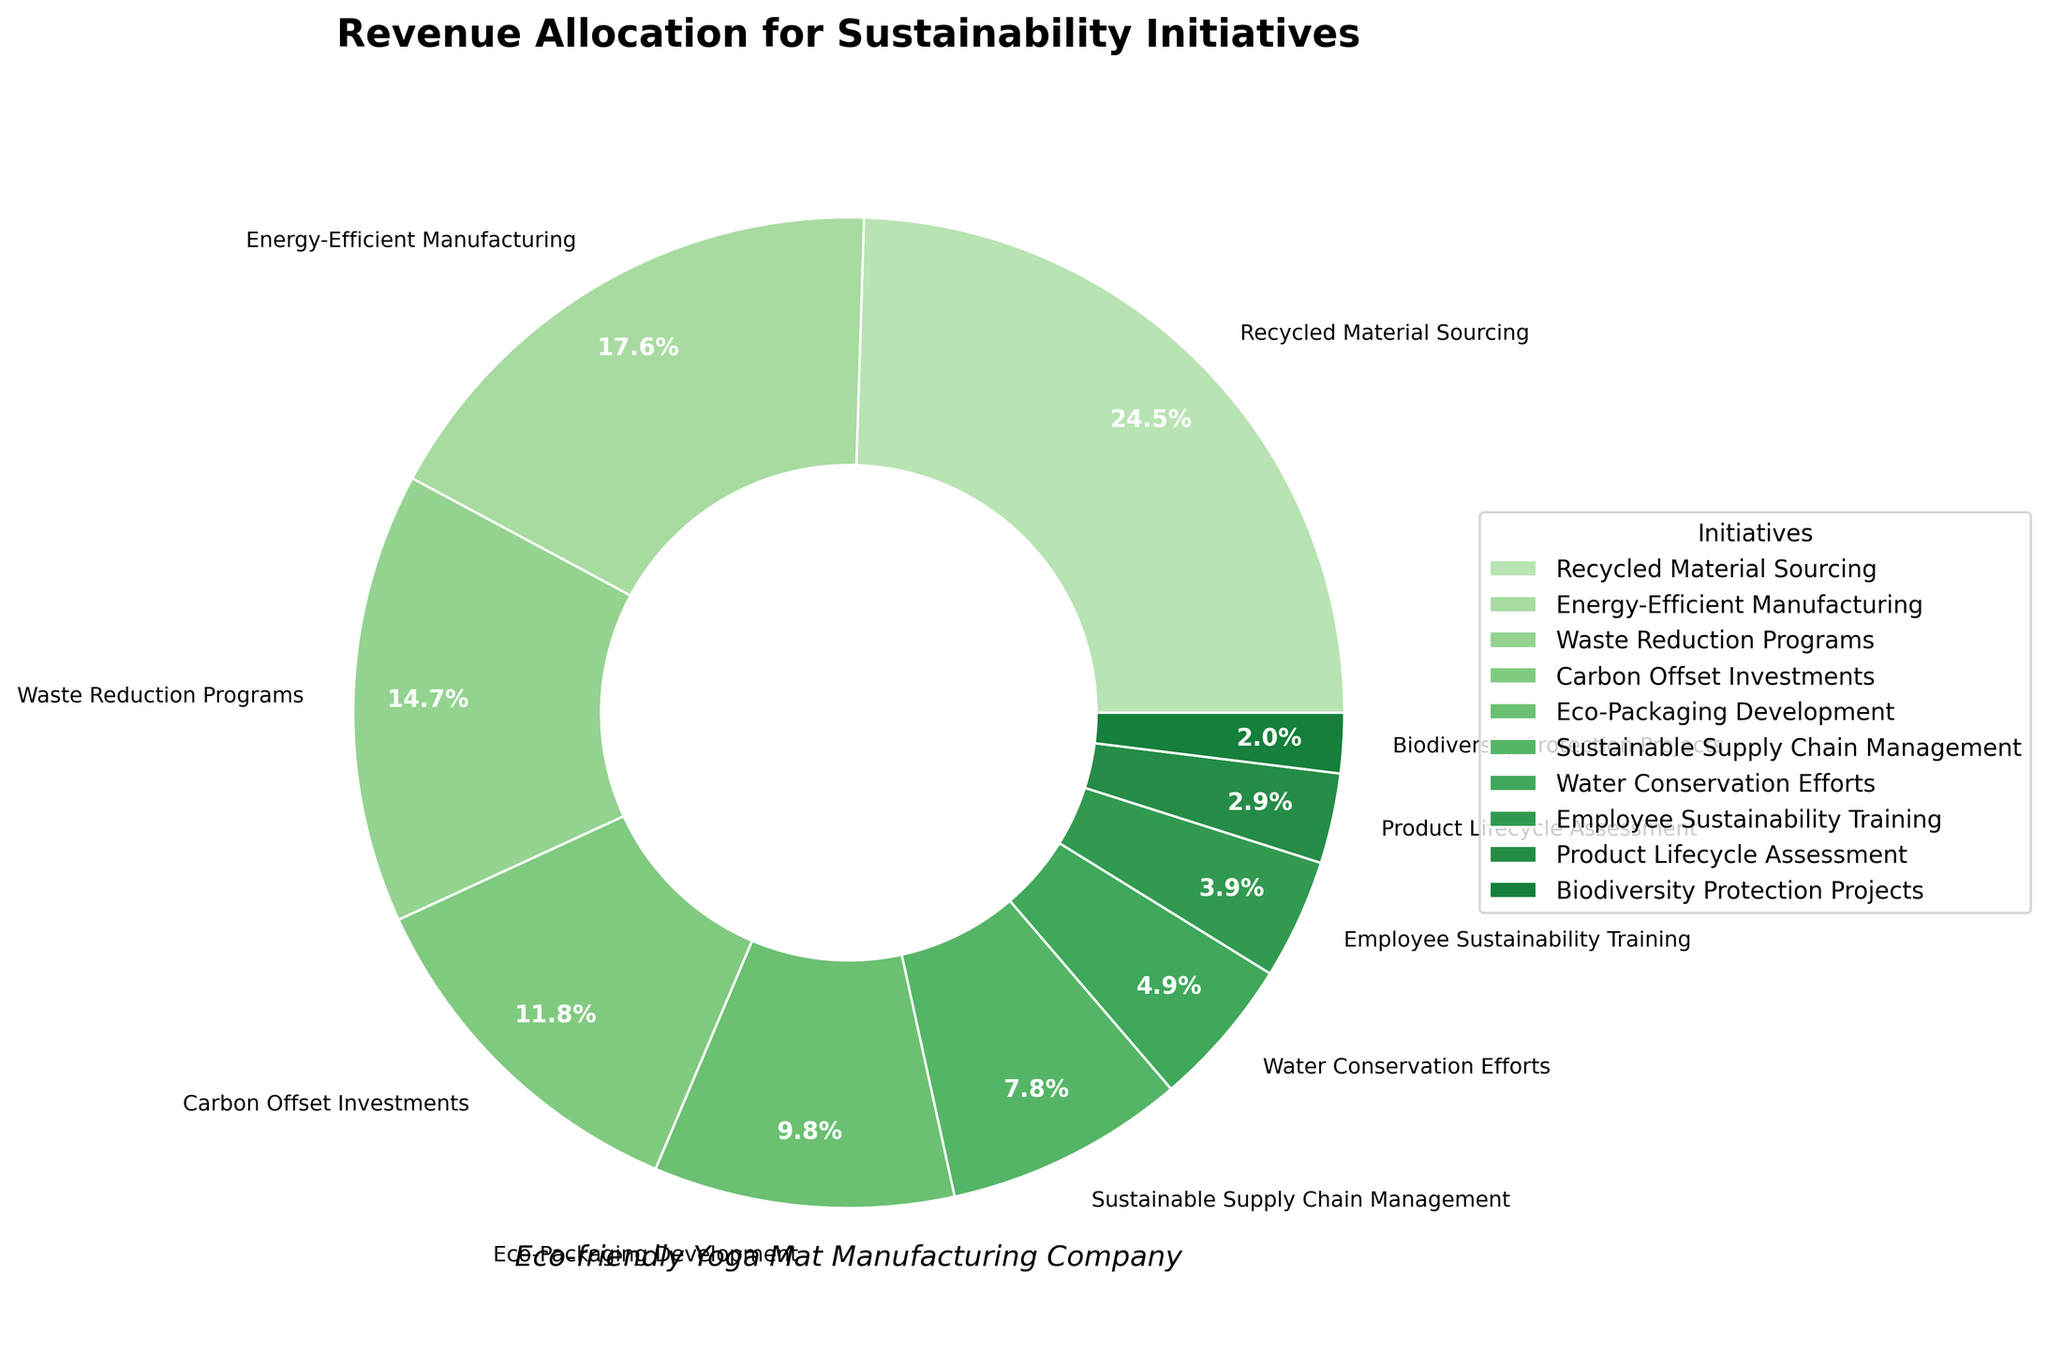Which initiative received the highest percentage of the revenue allocation? The initiative with the largest slice in the pie chart indicates the highest revenue allocation, which is "Recycled Material Sourcing" at 25%.
Answer: Recycled Material Sourcing Calculate the combined percentage of revenue allocation for "Eco-Packaging Development", "Sustainable Supply Chain Management", and "Water Conservation Efforts". Sum the percentages for each of these initiatives: 10% + 8% + 5% = 23%.
Answer: 23% How much more percentage is allocated to "Energy-Efficient Manufacturing" than "Employee Sustainability Training"? Subtract the percentage of "Employee Sustainability Training" from "Energy-Efficient Manufacturing": 18% - 4% = 14%.
Answer: 14% Which initiative has a lower allocation: "Carbon Offset Investments" or "Waste Reduction Programs"? "Waste Reduction Programs" has 15% and "Carbon Offset Investments" has 12%, so "Carbon Offset Investments" has a lower allocation.
Answer: Carbon Offset Investments What is the total percentage of revenue allocation for initiatives aimed at reducing environmental impact, such as "Waste Reduction Programs", "Carbon Offset Investments", and "Water Conservation Efforts"? Sum the percentages for each of these initiatives: 15% + 12% + 5% = 32%.
Answer: 32% How many initiatives have an allocation of less than 10%? Count the initiatives with percentages less than 10%: "Sustainable Supply Chain Management" (8%), "Water Conservation Efforts" (5%), "Employee Sustainability Training" (4%), "Product Lifecycle Assessment" (3%), "Biodiversity Protection Projects" (2%). There are 5 initiatives.
Answer: 5 Compare the allocation for "Recycled Material Sourcing" and "Energy-Efficient Manufacturing". Which is higher and by how much? "Recycled Material Sourcing" is 25%, and "Energy-Efficient Manufacturing" is 18%. Subtract the smaller percentage from the larger: 25% - 18% = 7%. "Recycled Material Sourcing" is higher by 7%.
Answer: Recycled Material Sourcing by 7% Is the allocation for "Water Conservation Efforts" greater than that for "Product Lifecycle Assessment"? "Water Conservation Efforts" has 5%, and "Product Lifecycle Assessment" has 3%. 5% is greater than 3%.
Answer: Yes What percentage is allocated to initiatives not directly tied to product development, such as "Employee Sustainability Training" and "Biodiversity Protection Projects"? Sum the percentages for these initiatives: 4% + 2% = 6%.
Answer: 6% What is the percentage difference between the highest and lowest revenue allocations? Subtract the smallest percentage (2% for "Biodiversity Protection Projects") from the largest percentage (25% for "Recycled Material Sourcing"): 25% - 2% = 23%.
Answer: 23% 